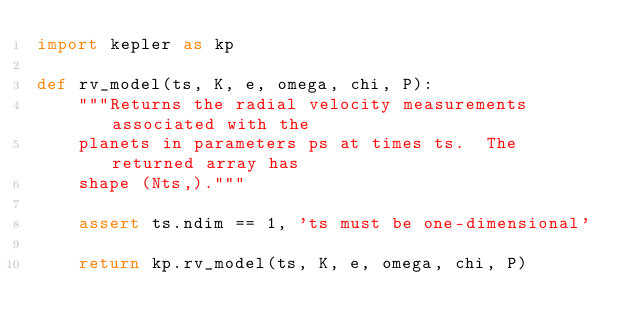Convert code to text. <code><loc_0><loc_0><loc_500><loc_500><_Python_>import kepler as kp

def rv_model(ts, K, e, omega, chi, P):
    """Returns the radial velocity measurements associated with the
    planets in parameters ps at times ts.  The returned array has
    shape (Nts,)."""

    assert ts.ndim == 1, 'ts must be one-dimensional'

    return kp.rv_model(ts, K, e, omega, chi, P)
</code> 